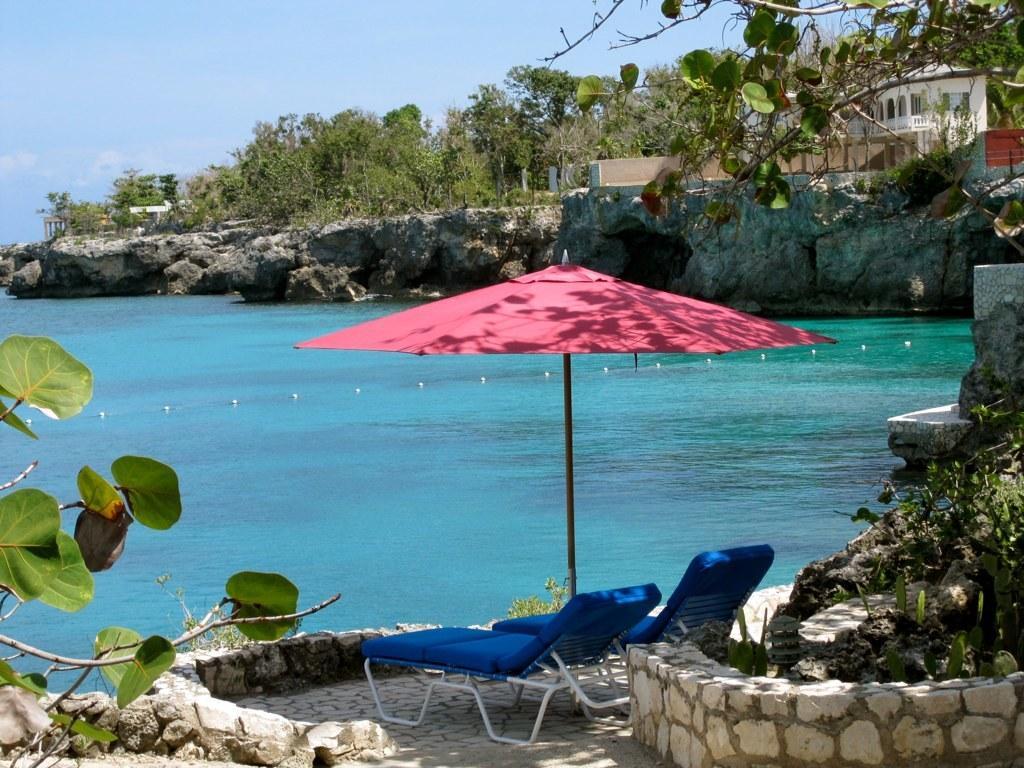How would you summarize this image in a sentence or two? In this image, we can see blue chairs on the floor. Few plants, trees we can see here. In the middle of the image, there is an umbrella with pole, water. Top of the image, we can see few houses with walls, pillars. Background there is a sky. 